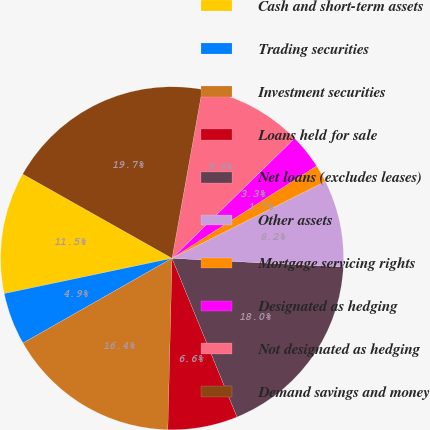Convert chart to OTSL. <chart><loc_0><loc_0><loc_500><loc_500><pie_chart><fcel>Cash and short-term assets<fcel>Trading securities<fcel>Investment securities<fcel>Loans held for sale<fcel>Net loans (excludes leases)<fcel>Other assets<fcel>Mortgage servicing rights<fcel>Designated as hedging<fcel>Not designated as hedging<fcel>Demand savings and money<nl><fcel>11.47%<fcel>4.93%<fcel>16.38%<fcel>6.57%<fcel>18.01%<fcel>8.2%<fcel>1.66%<fcel>3.29%<fcel>9.84%<fcel>19.65%<nl></chart> 